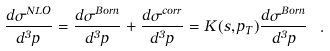<formula> <loc_0><loc_0><loc_500><loc_500>\frac { d \sigma ^ { N L O } } { d ^ { 3 } p } = \frac { d \sigma ^ { B o r n } } { d ^ { 3 } p } + \frac { d \sigma ^ { c o r r } } { d ^ { 3 } p } = K ( s , p _ { T } ) \frac { d \sigma ^ { B o r n } } { d ^ { 3 } p } \ .</formula> 